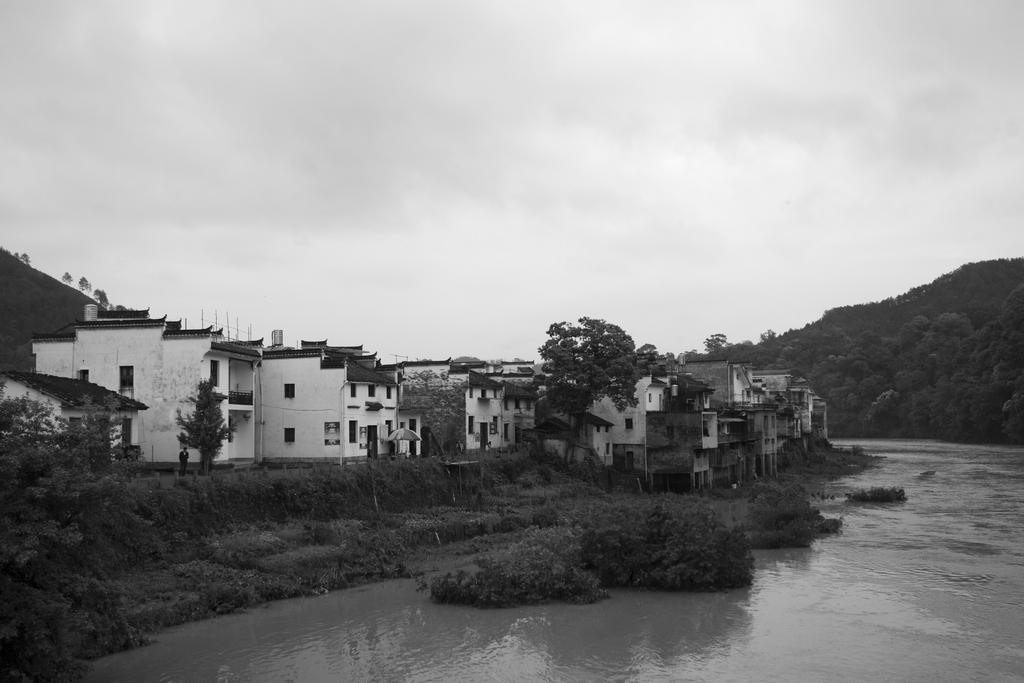How would you summarize this image in a sentence or two? At the bottom of the image there is water. Behind the water on the ground there are plants and trees. And in the background there are houses with walls, roofs and windows. At the right corner of the image there is a hill with trees. At the top of the image there is a sky with clouds. 